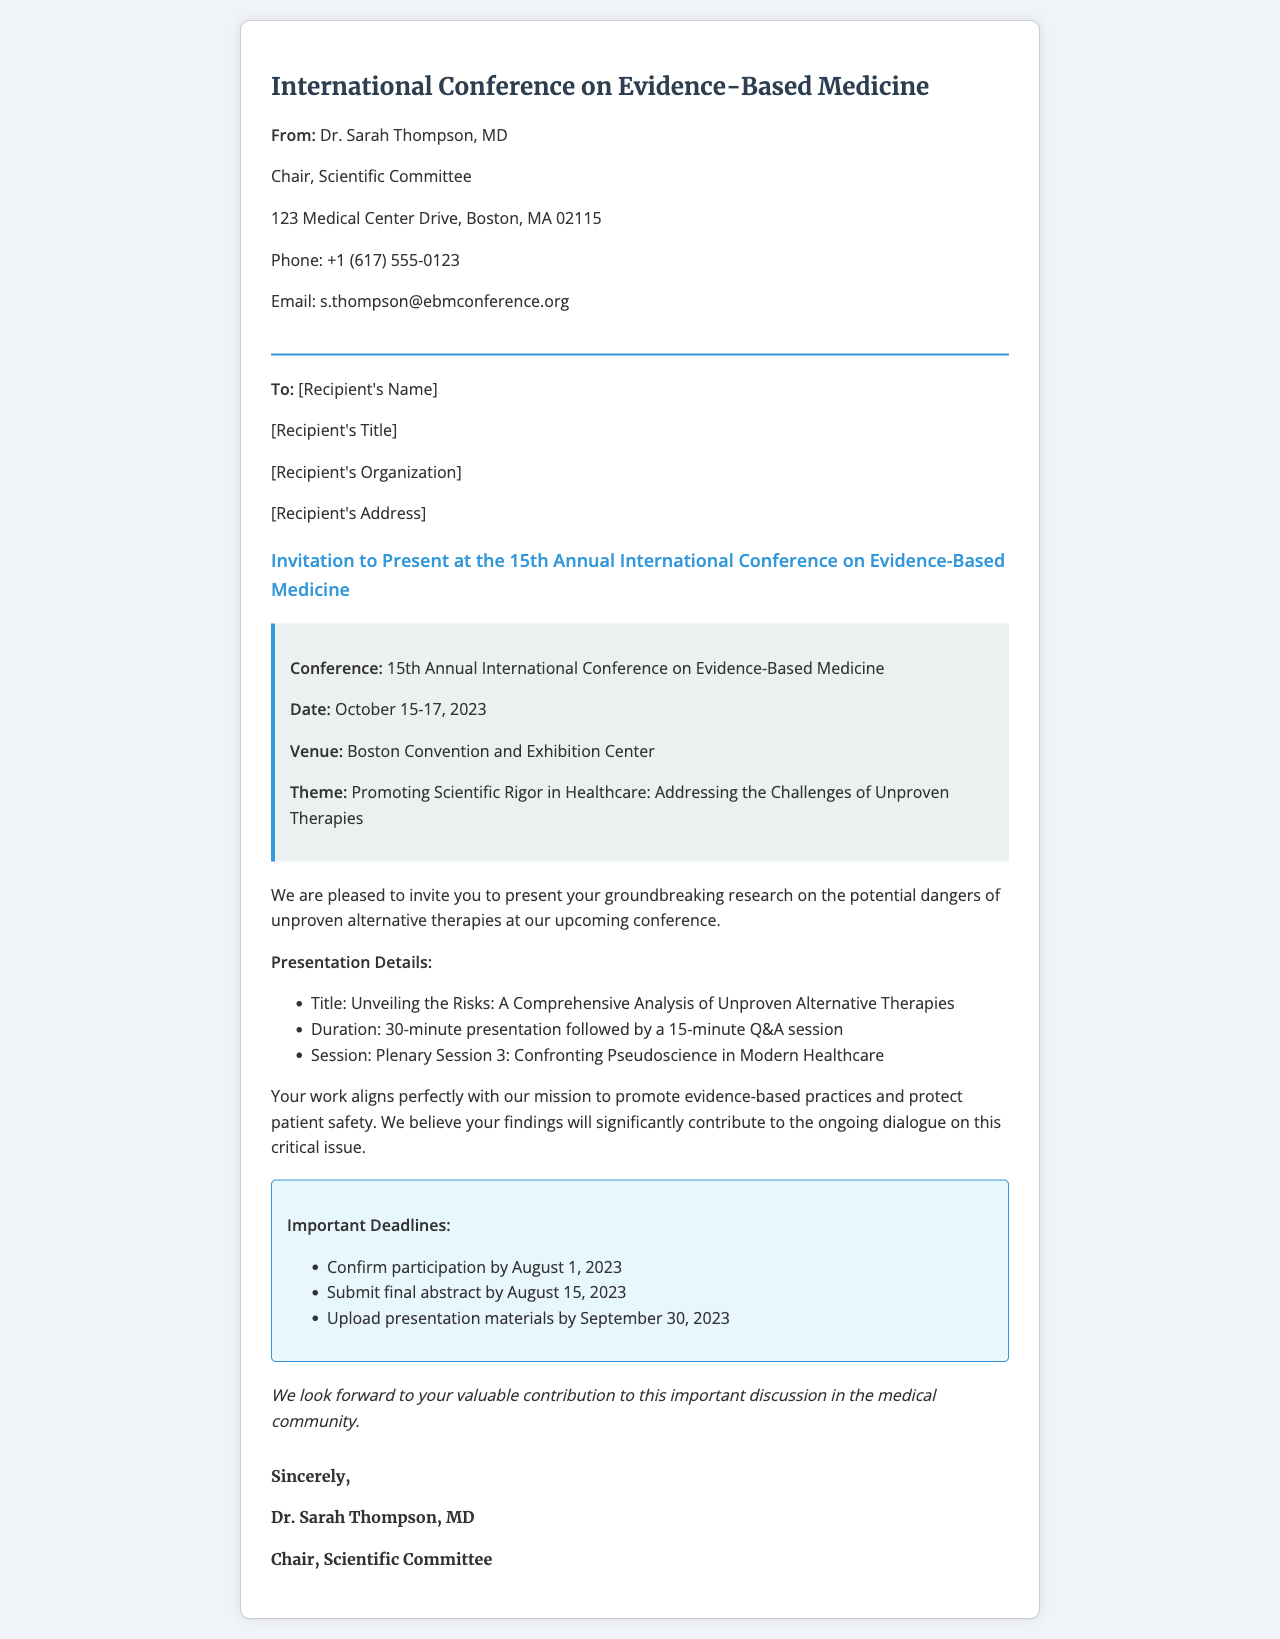what is the name of the conference? The name of the conference is explicitly mentioned in the header of the document.
Answer: International Conference on Evidence-Based Medicine who is the sender of the fax? The sender’s details, including name and title, are listed in the "From" section of the document.
Answer: Dr. Sarah Thompson, MD what are the conference dates? The conference dates are stated in the conference details section of the document.
Answer: October 15-17, 2023 what is the title of the presentation? The title of the presentation is highlighted in the invitation body section.
Answer: Unveiling the Risks: A Comprehensive Analysis of Unproven Alternative Therapies what session will the presentation be part of? The session information is provided within the presentation details listed in the invitation.
Answer: Plenary Session 3: Confronting Pseudoscience in Modern Healthcare what is the deadline to confirm participation? The important deadlines for participation are mentioned in the specific deadlines section.
Answer: August 1, 2023 how long is the presentation duration? The duration is mentioned directly in the presentation details section.
Answer: 30-minute presentation what is the theme of the conference? The theme of the conference is specified in the conference details area.
Answer: Promoting Scientific Rigor in Healthcare: Addressing the Challenges of Unproven Therapies who should the recipient contact for more information? The contact information is provided in the "From" section, explicitly mentioned.
Answer: Dr. Sarah Thompson, MD 